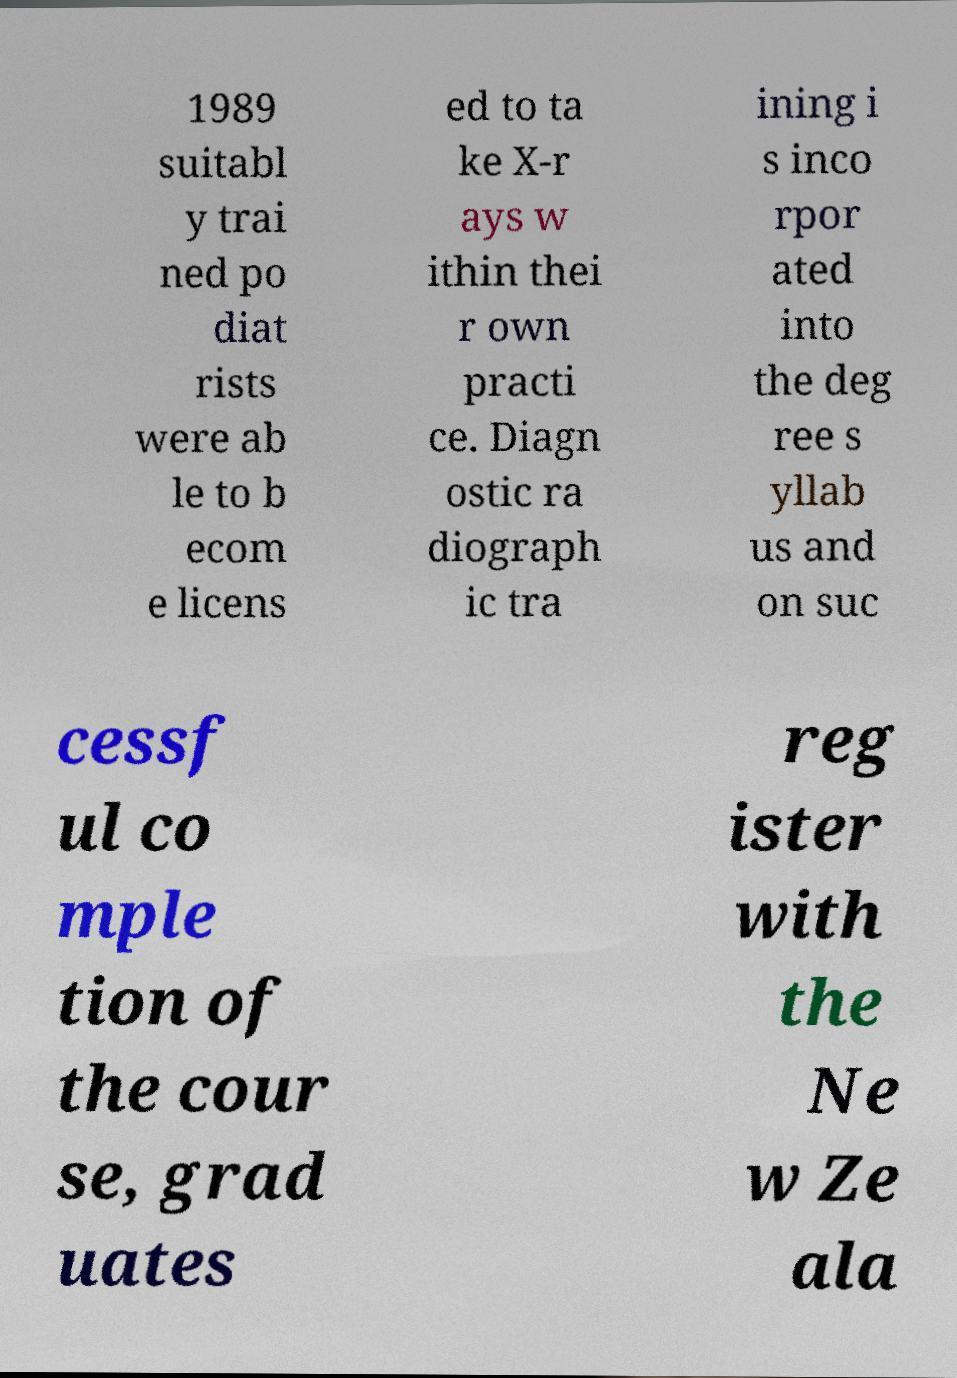Please identify and transcribe the text found in this image. 1989 suitabl y trai ned po diat rists were ab le to b ecom e licens ed to ta ke X-r ays w ithin thei r own practi ce. Diagn ostic ra diograph ic tra ining i s inco rpor ated into the deg ree s yllab us and on suc cessf ul co mple tion of the cour se, grad uates reg ister with the Ne w Ze ala 